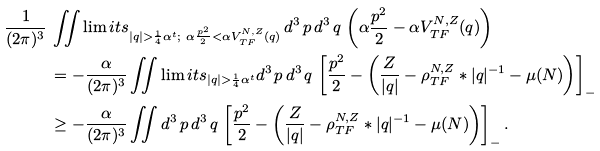<formula> <loc_0><loc_0><loc_500><loc_500>\frac { 1 } { ( 2 \pi ) ^ { 3 } } \, & \iint \lim i t s _ { | q | > \frac { 1 } { 4 } \alpha ^ { t } ; \ \alpha \frac { p ^ { 2 } } { 2 } < \alpha V _ { T F } ^ { N , Z } ( q ) } \, d ^ { 3 } \, p \, d ^ { 3 } \, q \, \left ( \alpha \frac { p ^ { 2 } } { 2 } - \alpha V _ { T F } ^ { N , Z } ( q ) \right ) \\ & = - \frac { \alpha } { ( 2 \pi ) ^ { 3 } } \iint \lim i t s _ { | q | > \frac { 1 } { 4 } \alpha ^ { t } } d ^ { 3 } \, p \, d ^ { 3 } \, q \, \left [ \frac { p ^ { 2 } } { 2 } - \left ( \frac { Z } { | q | } - \rho _ { T F } ^ { N , Z } * | q | ^ { - 1 } - \mu ( N ) \right ) \right ] _ { - } \\ & \geq - \frac { \alpha } { ( 2 \pi ) ^ { 3 } } \iint d ^ { 3 } \, p \, d ^ { 3 } \, q \, \left [ \frac { p ^ { 2 } } { 2 } - \left ( \frac { Z } { | q | } - \rho _ { T F } ^ { N , Z } * | q | ^ { - 1 } - \mu ( N ) \right ) \right ] _ { - } .</formula> 